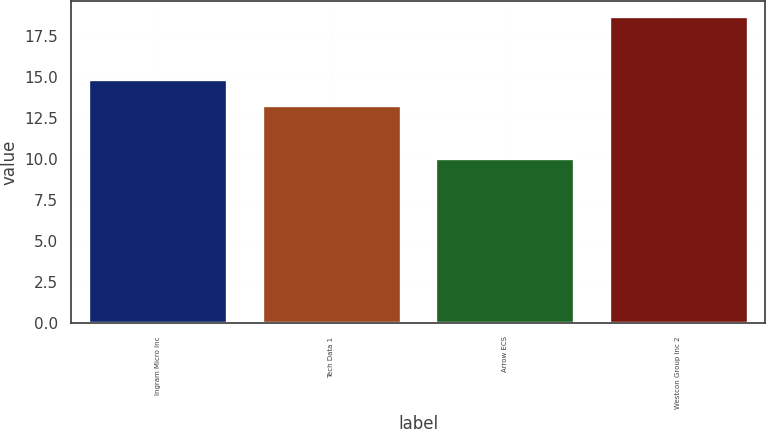<chart> <loc_0><loc_0><loc_500><loc_500><bar_chart><fcel>Ingram Micro Inc<fcel>Tech Data 1<fcel>Arrow ECS<fcel>Westcon Group Inc 2<nl><fcel>14.9<fcel>13.3<fcel>10.1<fcel>18.7<nl></chart> 